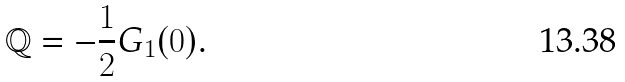Convert formula to latex. <formula><loc_0><loc_0><loc_500><loc_500>\mathbb { Q } = - \frac { 1 } { 2 } G _ { 1 } ( 0 ) .</formula> 